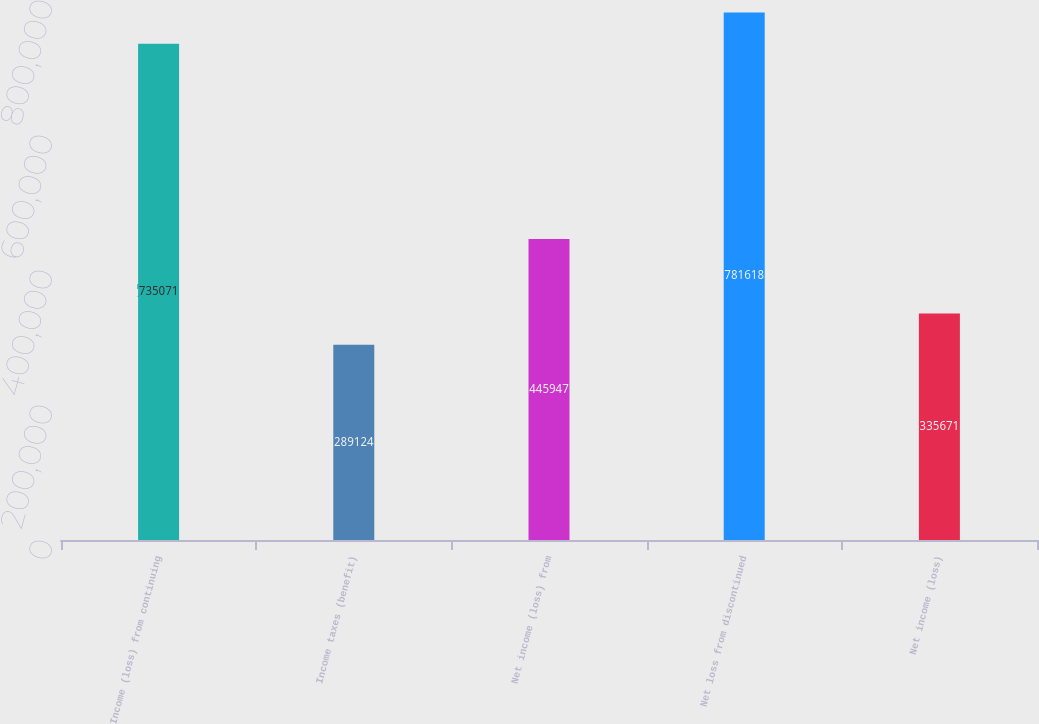Convert chart. <chart><loc_0><loc_0><loc_500><loc_500><bar_chart><fcel>Income (loss) from continuing<fcel>Income taxes (benefit)<fcel>Net income (loss) from<fcel>Net loss from discontinued<fcel>Net income (loss)<nl><fcel>735071<fcel>289124<fcel>445947<fcel>781618<fcel>335671<nl></chart> 